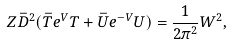Convert formula to latex. <formula><loc_0><loc_0><loc_500><loc_500>Z \bar { D } ^ { 2 } ( \bar { T } e ^ { V } T + \bar { U } e ^ { - V } U ) = \frac { 1 } { 2 \pi ^ { 2 } } W ^ { 2 } ,</formula> 